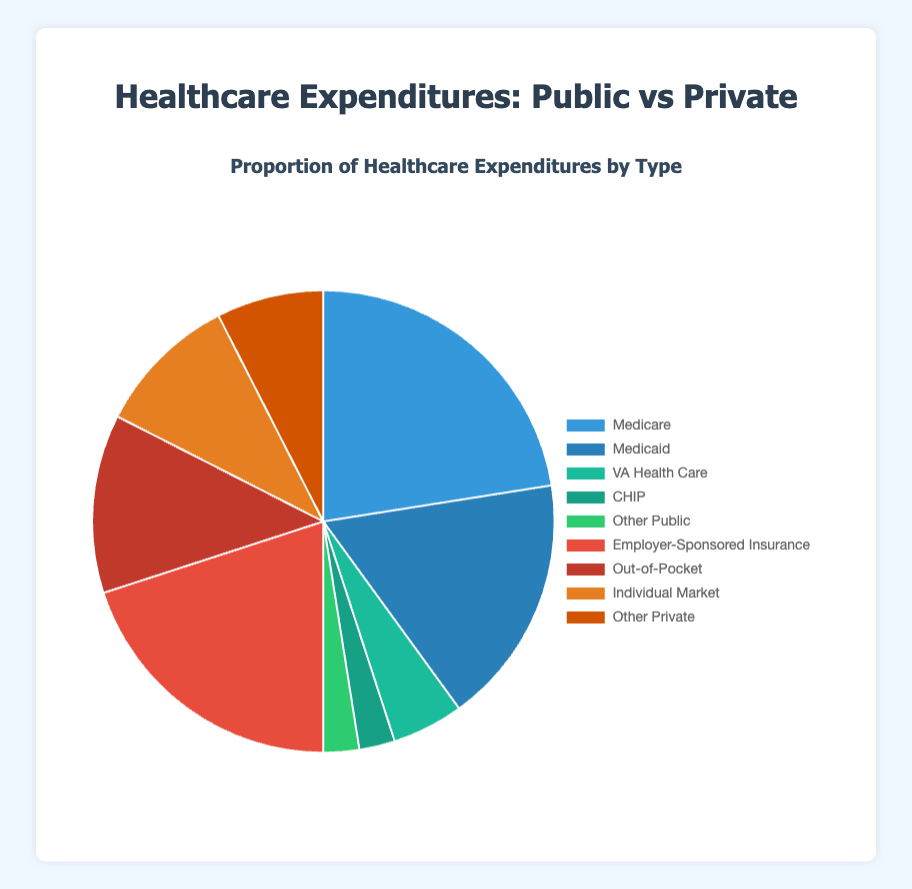Which category of healthcare expenditure is the largest? By looking at the pie chart, the largest segment corresponds to Medicare, which is a part of the Public category.
Answer: Medicare What is the combined proportion of Public healthcare expenditures? Public healthcare expenditures include Medicare (45%), Medicaid (35%), VA Health Care (10%), CHIP (5%), and Other Public (5%). Adding these proportions together yields 45 + 35 + 10 + 5 + 5 = 100%.
Answer: 100% Is the Out-of-Pocket expenditure higher or lower than Employer-Sponsored Insurance? By comparing the sizes of the pie chart segments, Employer-Sponsored Insurance is 40% whereas Out-of-Pocket is 25%, showing that Out-of-Pocket is lower.
Answer: Lower How does Individual Market compare to Medicaid in terms of proportion? The pie chart shows that Medicaid constitutes 35% of the expenditures, whereas Individual Market accounts for 20%. Thus, Medicaid is higher than Individual Market.
Answer: Medicaid is higher Which segments are represented with shades of green in the pie chart? The pie chart uses different colors to distinguish the segments. Shades of green correspond to VA Health Care (10%), CHIP (5%), and Other Public (5%).
Answer: VA Health Care, CHIP, Other Public What is the difference between the largest public expenditure and the largest private expenditure? The largest public expenditure is Medicare (45%) and the largest private expenditure is Employer-Sponsored Insurance (40%). The difference is 45% - 40% = 5%.
Answer: 5% What is the total proportion of expenditures that are less than 10%? The segments less than 10% are VA Health Care (10%), CHIP (5%), and Other Public (5%) individually, and adding them gives 10% + 5% + 5% = 20%.
Answer: 20% If the categories "Other Public" and "Other Private" were combined, what proportion would they constitute? Combining Other Public (5%) and Other Private (15%), we get 5% + 15% = 20%.
Answer: 20% What is the visual difference in size between Medicaid and Out-of-Pocket expenditures? Visually, Medicaid is represented by a larger segment of the pie chart compared to Out-of-Pocket. Medicaid is 35% while Out-of-Pocket is 25%.
Answer: Medicaid is larger How much more is spent on Employer-Sponsored Insurance compared to Individual Market? From the pie chart, Employer-Sponsored Insurance is 40% and Individual Market is 20%. Therefore, the difference is 40% - 20% = 20%.
Answer: 20% 